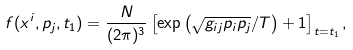Convert formula to latex. <formula><loc_0><loc_0><loc_500><loc_500>f ( x ^ { i } , p _ { j } , t _ { 1 } ) = \frac { N } { ( 2 \pi ) ^ { 3 } } \left [ \exp \left ( \sqrt { g _ { i j } p _ { i } p _ { j } } / T \right ) + 1 \right ] _ { t = t _ { 1 } } ,</formula> 